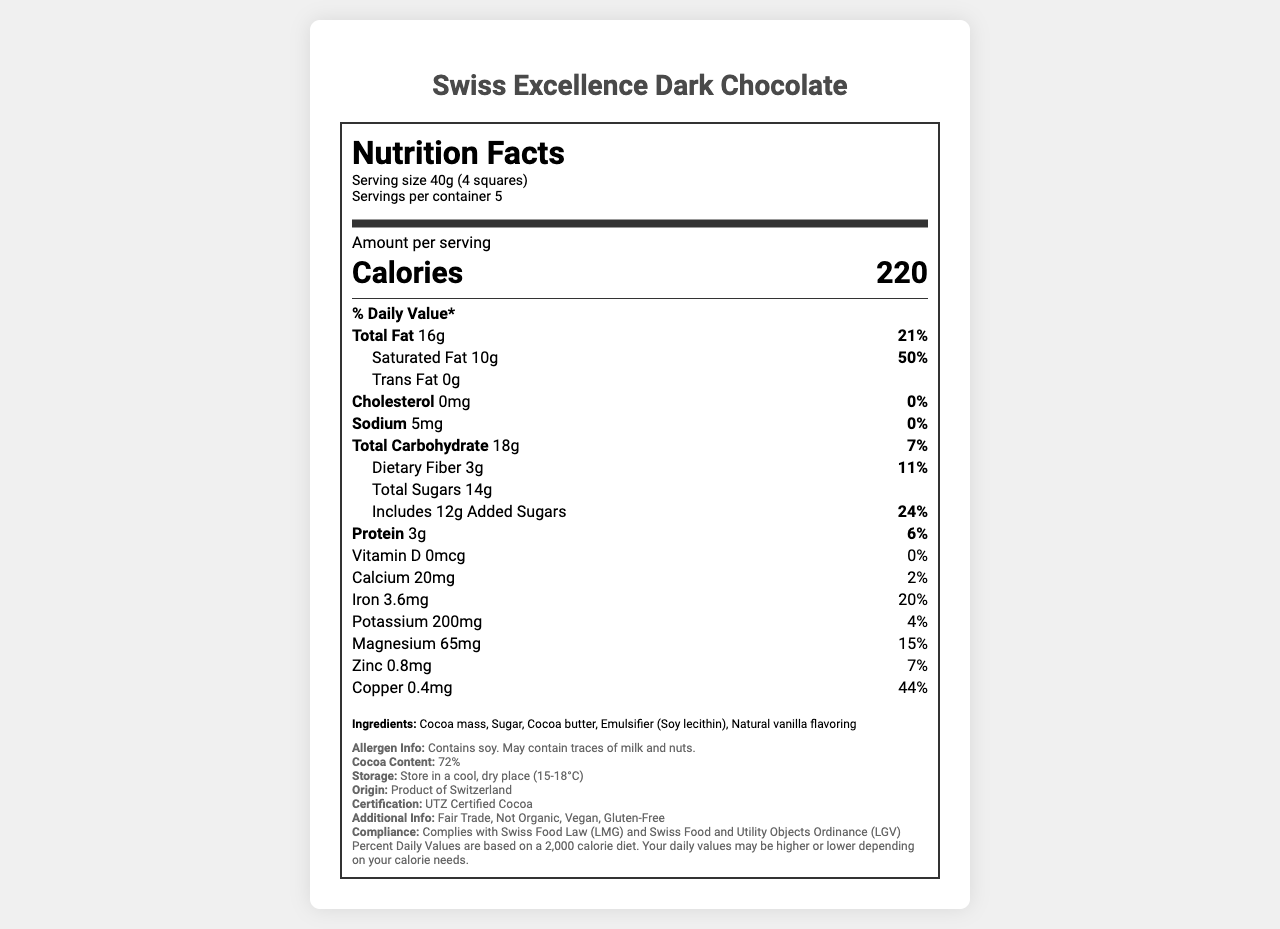what is the serving size for Swiss Excellence Dark Chocolate? The serving size is mentioned under the serving info section: Serving size 40g (4 squares).
Answer: 40g (4 squares) what is the daily value percentage of saturated fat per serving? The daily value percentage for saturated fat is provided directly under the "Total Fat" section: Saturated Fat 10g 50%.
Answer: 50% how many servings are in a container of this chocolate? The number of servings per container is listed in the serving info section: Servings per container 5.
Answer: 5 what is the amount of dietary fiber per serving? The document shows dietary fiber amount under the "Total Carbohydrate" section: Dietary Fiber 3g 11%.
Answer: 3g how much iron is present in a serving of this chocolate? The document states Iron content directly under the nutrient list: Iron 3.6mg 20%.
Answer: 3.6mg how many calories are there in one serving of this chocolate bar? The label under the "Amount per serving" section prominently displays the calorie count: Calories 220.
Answer: 220 what certifications does Swiss Excellence Dark Chocolate hold? The certification info states that the product is UTZ Certified: Certification: UTZ Certified Cocoa.
Answer: UTZ Certified Cocoa is this chocolate bar vegan? Under the additional info, it is mentioned that the product is Vegan: Additional Info: Vegan.
Answer: Yes is the country of origin mentioned in the document? The country of origin is stated as Switzerland: Origin: Product of Switzerland.
Answer: Yes is there any cholesterol in this chocolate? Cholesterol content records show 0mg and 0%: Cholesterol 0mg 0%.
Answer: No what percentage of the daily value for protein does one serving of this chocolate provide? The document lists the daily value percentage for protein directly under the nutrient list: Protein 3g 6%.
Answer: 6% which of the following is NOT an ingredient in Swiss Excellence Dark Chocolate? A. Cocoa mass B. Sugar C. Cocoa butter D. Milk The ingredient list includes Cocoa mass, Sugar, Cocoa butter, Emulsifier (Soy lecithin), and Natural vanilla flavoring but not Milk.
Answer: D how much added sugars are there per serving? A. 10g B. 12g C. 14g D. 16g The document specifies "Includes 12g Added Sugars” directly under total sugars: Includes 12g Added Sugars 24%.
Answer: B what is the total carbohydrate content per serving? "Total Carbohydrate" section shows 18g 7%, indicating the grams of total carbohydrate content.
Answer: 18g does this chocolate bar contain trans fat? The label shows the presence of trans fat as 0g: Trans Fat 0g.
Answer: No describe the main idea of the document The document offers a comprehensive overview of Swiss Excellence Dark Chocolate's nutritional aspects such as serving size, calories, fats, carbohydrates, sugars, protein, vitamins, minerals, and additional product details, all compiled in a standard nutrition facts label format.
Answer: The document provides detailed nutritional information for Swiss Excellence Dark Chocolate, including macronutrient and micronutrient breakdown, ingredients, allergen info, storage instructions, country of origin, and certifications, while complying with Swiss food laws. how is the chocolate stored? The storage instructions are provided as: Store in a cool, dry place (15-18°C).
Answer: Store in a cool, dry place (15-18°C) how many grams of calcium are in a serving? The document lists Calcium content as 20mg without indicating conversion to grams, providing insufficient data to answer the question accurately.
Answer: Not enough information 